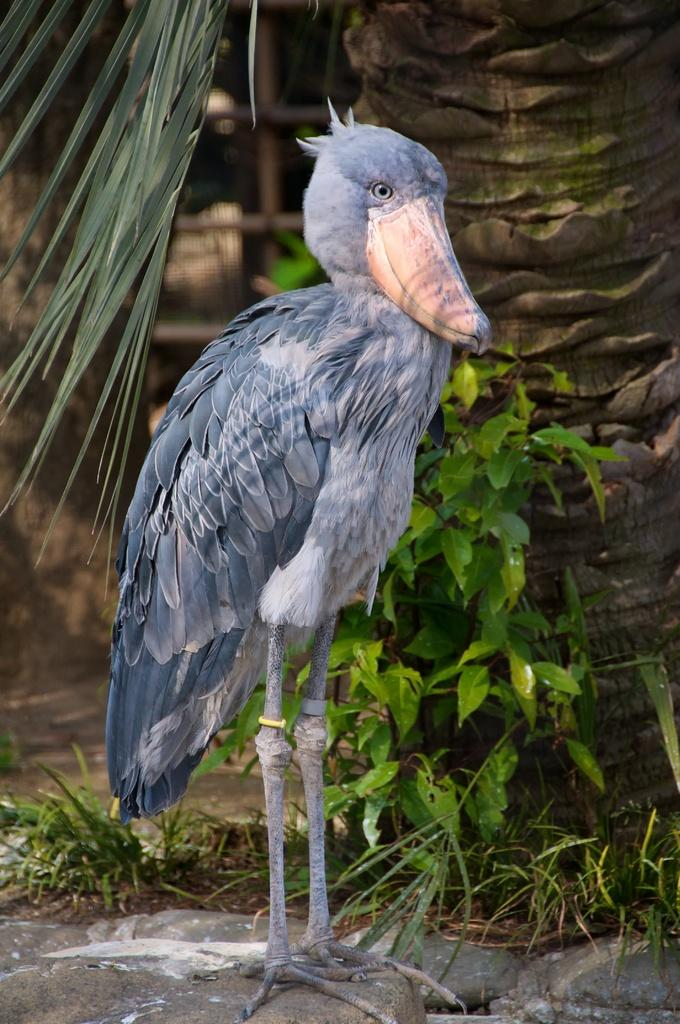What type of animal can be seen in the image? There is a bird in the image. How is the bird positioned in relation to other elements in the image? The bird is in front of other elements in the image. What type of vegetation is visible in the image? There are leaves visible in the image. What is the source of the leaves in the image? There is a tree in the image, which is the source of the leaves. What type of bells can be heard ringing in the image? There are no bells present in the image, and therefore no sound can be heard. 